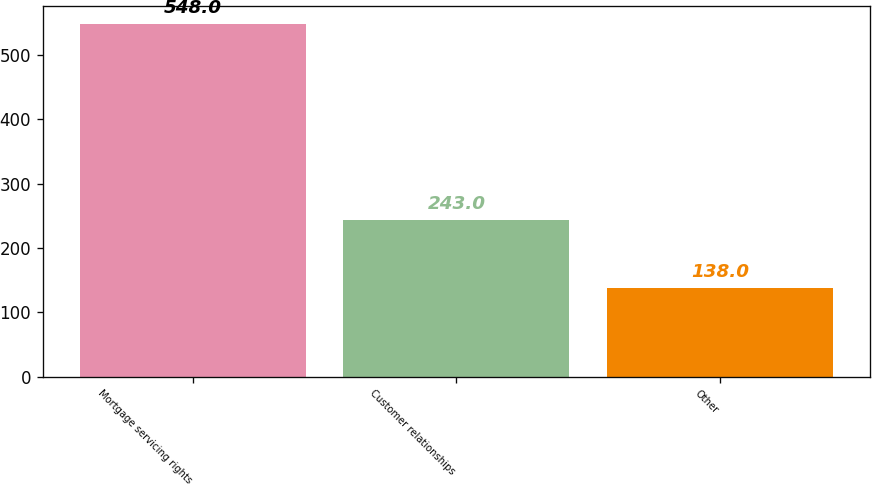Convert chart to OTSL. <chart><loc_0><loc_0><loc_500><loc_500><bar_chart><fcel>Mortgage servicing rights<fcel>Customer relationships<fcel>Other<nl><fcel>548<fcel>243<fcel>138<nl></chart> 